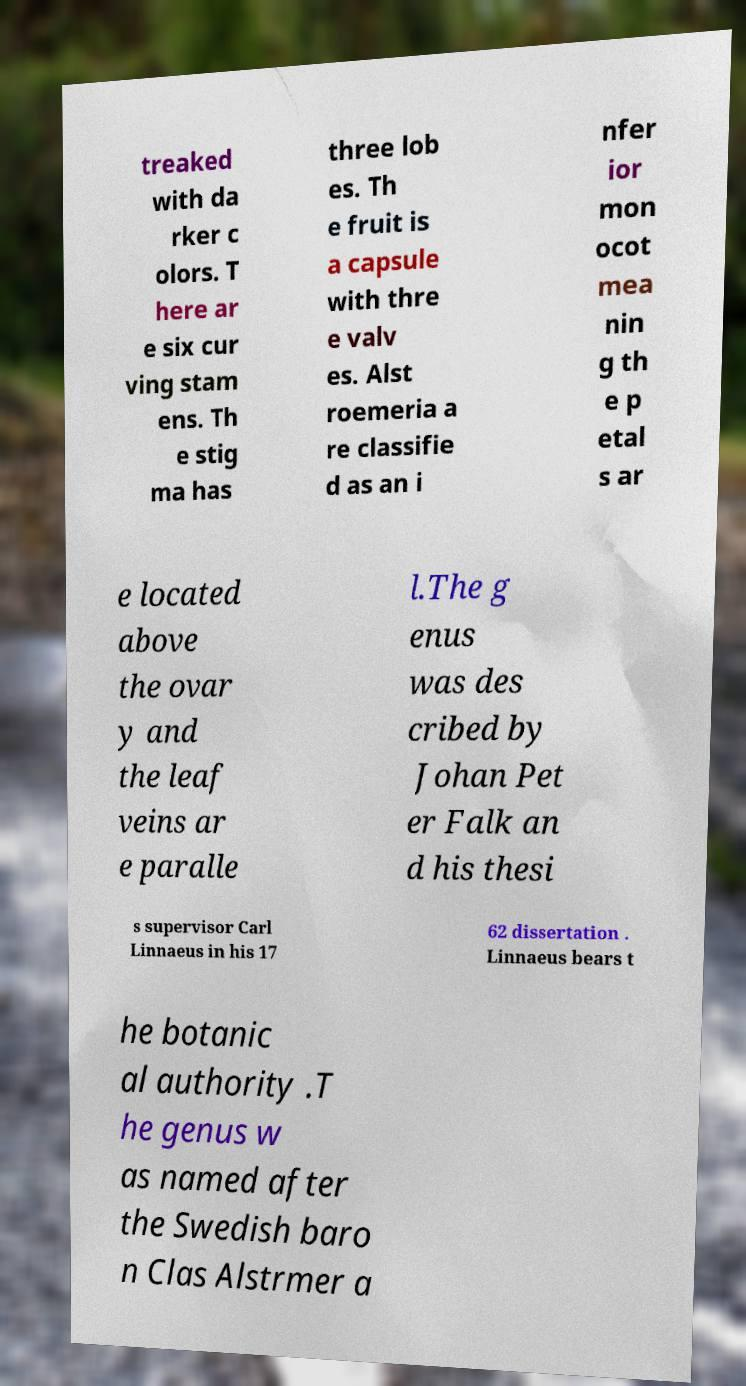Can you accurately transcribe the text from the provided image for me? treaked with da rker c olors. T here ar e six cur ving stam ens. Th e stig ma has three lob es. Th e fruit is a capsule with thre e valv es. Alst roemeria a re classifie d as an i nfer ior mon ocot mea nin g th e p etal s ar e located above the ovar y and the leaf veins ar e paralle l.The g enus was des cribed by Johan Pet er Falk an d his thesi s supervisor Carl Linnaeus in his 17 62 dissertation . Linnaeus bears t he botanic al authority .T he genus w as named after the Swedish baro n Clas Alstrmer a 